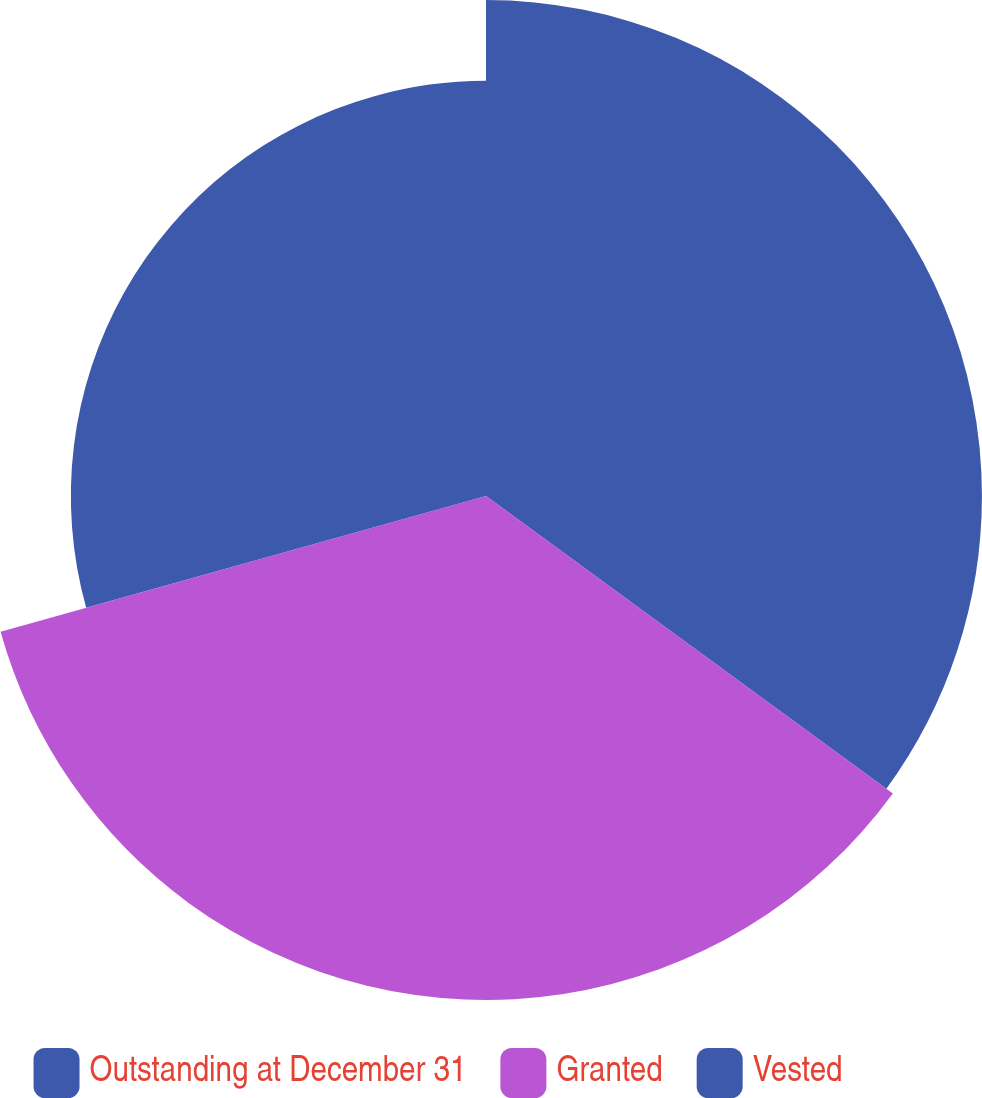<chart> <loc_0><loc_0><loc_500><loc_500><pie_chart><fcel>Outstanding at December 31<fcel>Granted<fcel>Vested<nl><fcel>35.05%<fcel>35.62%<fcel>29.34%<nl></chart> 